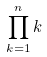Convert formula to latex. <formula><loc_0><loc_0><loc_500><loc_500>\prod _ { k = 1 } ^ { n } k</formula> 